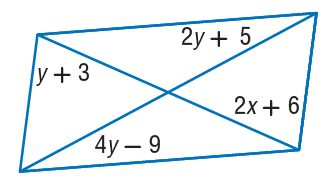Answer the mathemtical geometry problem and directly provide the correct option letter.
Question: Find y so that the quadrilateral is a parallelogram.
Choices: A: 7 B: 14 C: 15 D: 21 A 